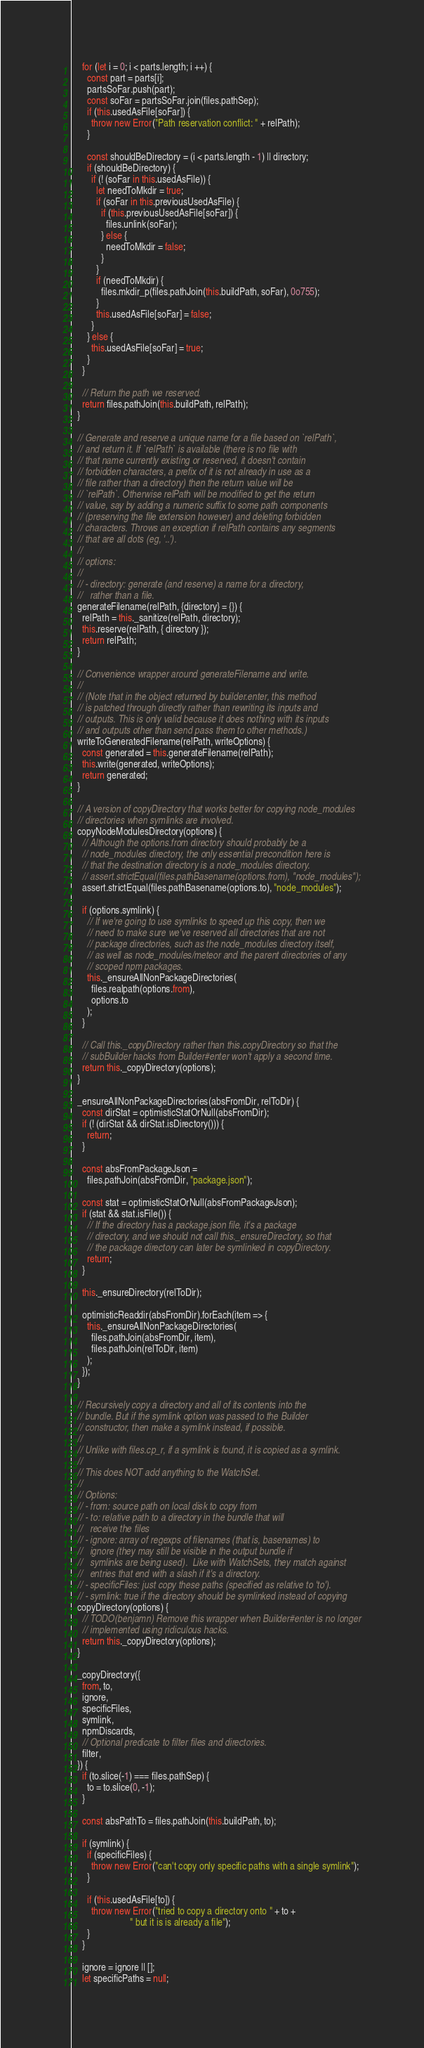Convert code to text. <code><loc_0><loc_0><loc_500><loc_500><_JavaScript_>    for (let i = 0; i < parts.length; i ++) {
      const part = parts[i];
      partsSoFar.push(part);
      const soFar = partsSoFar.join(files.pathSep);
      if (this.usedAsFile[soFar]) {
        throw new Error("Path reservation conflict: " + relPath);
      }

      const shouldBeDirectory = (i < parts.length - 1) || directory;
      if (shouldBeDirectory) {
        if (! (soFar in this.usedAsFile)) {
          let needToMkdir = true;
          if (soFar in this.previousUsedAsFile) {
            if (this.previousUsedAsFile[soFar]) {
              files.unlink(soFar);
            } else {
              needToMkdir = false;
            }
          }
          if (needToMkdir) {
            files.mkdir_p(files.pathJoin(this.buildPath, soFar), 0o755);
          }
          this.usedAsFile[soFar] = false;
        }
      } else {
        this.usedAsFile[soFar] = true;
      }
    }

    // Return the path we reserved.
    return files.pathJoin(this.buildPath, relPath);
  }

  // Generate and reserve a unique name for a file based on `relPath`,
  // and return it. If `relPath` is available (there is no file with
  // that name currently existing or reserved, it doesn't contain
  // forbidden characters, a prefix of it is not already in use as a
  // file rather than a directory) then the return value will be
  // `relPath`. Otherwise relPath will be modified to get the return
  // value, say by adding a numeric suffix to some path components
  // (preserving the file extension however) and deleting forbidden
  // characters. Throws an exception if relPath contains any segments
  // that are all dots (eg, '..').
  //
  // options:
  //
  // - directory: generate (and reserve) a name for a directory,
  //   rather than a file.
  generateFilename(relPath, {directory} = {}) {
    relPath = this._sanitize(relPath, directory);
    this.reserve(relPath, { directory });
    return relPath;
  }

  // Convenience wrapper around generateFilename and write.
  //
  // (Note that in the object returned by builder.enter, this method
  // is patched through directly rather than rewriting its inputs and
  // outputs. This is only valid because it does nothing with its inputs
  // and outputs other than send pass them to other methods.)
  writeToGeneratedFilename(relPath, writeOptions) {
    const generated = this.generateFilename(relPath);
    this.write(generated, writeOptions);
    return generated;
  }

  // A version of copyDirectory that works better for copying node_modules
  // directories when symlinks are involved.
  copyNodeModulesDirectory(options) {
    // Although the options.from directory should probably be a
    // node_modules directory, the only essential precondition here is
    // that the destination directory is a node_modules directory.
    // assert.strictEqual(files.pathBasename(options.from), "node_modules");
    assert.strictEqual(files.pathBasename(options.to), "node_modules");

    if (options.symlink) {
      // If we're going to use symlinks to speed up this copy, then we
      // need to make sure we've reserved all directories that are not
      // package directories, such as the node_modules directory itself,
      // as well as node_modules/meteor and the parent directories of any
      // scoped npm packages.
      this._ensureAllNonPackageDirectories(
        files.realpath(options.from),
        options.to
      );
    }

    // Call this._copyDirectory rather than this.copyDirectory so that the
    // subBuilder hacks from Builder#enter won't apply a second time.
    return this._copyDirectory(options);
  }

  _ensureAllNonPackageDirectories(absFromDir, relToDir) {
    const dirStat = optimisticStatOrNull(absFromDir);
    if (! (dirStat && dirStat.isDirectory())) {
      return;
    }

    const absFromPackageJson =
      files.pathJoin(absFromDir, "package.json");

    const stat = optimisticStatOrNull(absFromPackageJson);
    if (stat && stat.isFile()) {
      // If the directory has a package.json file, it's a package
      // directory, and we should not call this._ensureDirectory, so that
      // the package directory can later be symlinked in copyDirectory.
      return;
    }

    this._ensureDirectory(relToDir);

    optimisticReaddir(absFromDir).forEach(item => {
      this._ensureAllNonPackageDirectories(
        files.pathJoin(absFromDir, item),
        files.pathJoin(relToDir, item)
      );
    });
  }

  // Recursively copy a directory and all of its contents into the
  // bundle. But if the symlink option was passed to the Builder
  // constructor, then make a symlink instead, if possible.
  //
  // Unlike with files.cp_r, if a symlink is found, it is copied as a symlink.
  //
  // This does NOT add anything to the WatchSet.
  //
  // Options:
  // - from: source path on local disk to copy from
  // - to: relative path to a directory in the bundle that will
  //   receive the files
  // - ignore: array of regexps of filenames (that is, basenames) to
  //   ignore (they may still be visible in the output bundle if
  //   symlinks are being used).  Like with WatchSets, they match against
  //   entries that end with a slash if it's a directory.
  // - specificFiles: just copy these paths (specified as relative to 'to').
  // - symlink: true if the directory should be symlinked instead of copying
  copyDirectory(options) {
    // TODO(benjamn) Remove this wrapper when Builder#enter is no longer
    // implemented using ridiculous hacks.
    return this._copyDirectory(options);
  }

  _copyDirectory({
    from, to,
    ignore,
    specificFiles,
    symlink,
    npmDiscards,
    // Optional predicate to filter files and directories.
    filter,
  }) {
    if (to.slice(-1) === files.pathSep) {
      to = to.slice(0, -1);
    }

    const absPathTo = files.pathJoin(this.buildPath, to);

    if (symlink) {
      if (specificFiles) {
        throw new Error("can't copy only specific paths with a single symlink");
      }

      if (this.usedAsFile[to]) {
        throw new Error("tried to copy a directory onto " + to +
                        " but it is is already a file");
      }
    }

    ignore = ignore || [];
    let specificPaths = null;</code> 